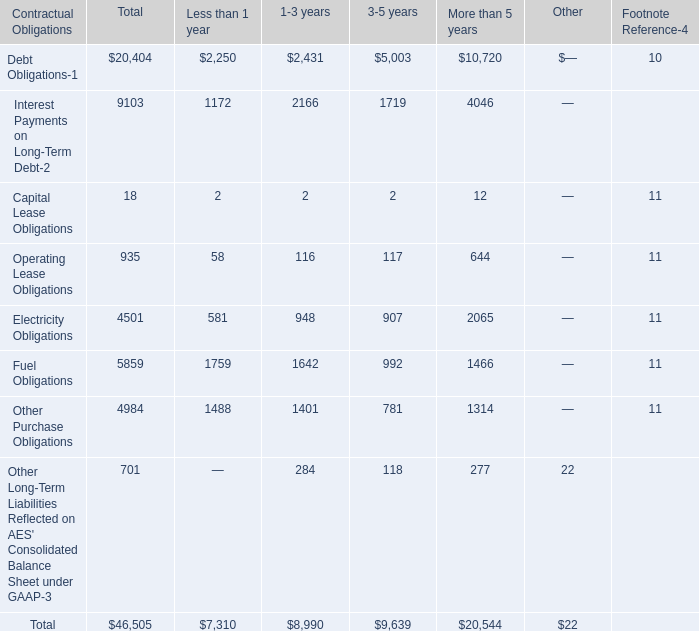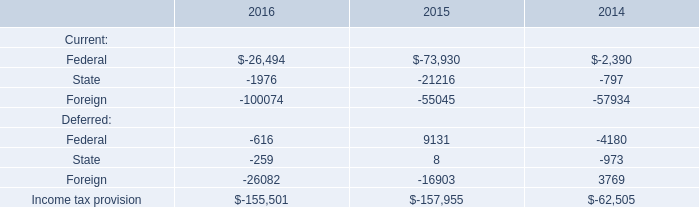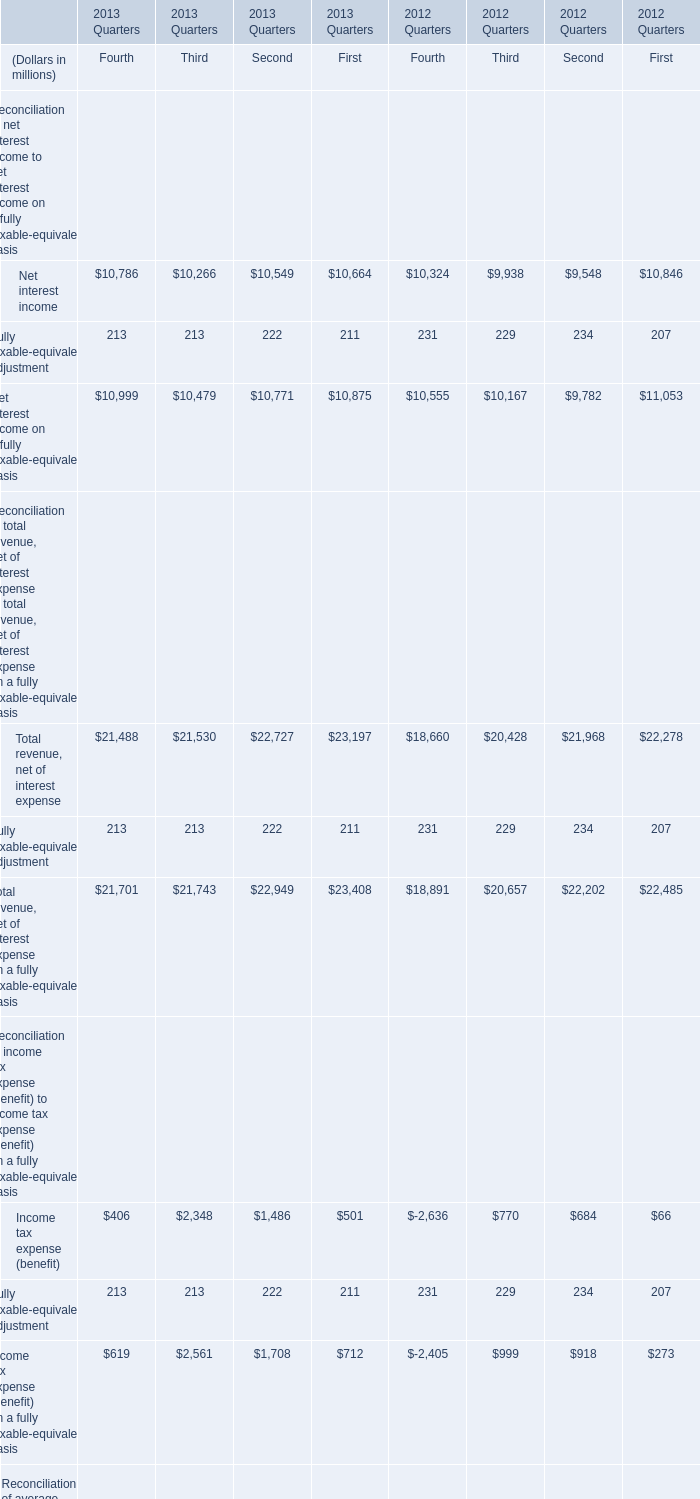what percent of debt obligations are long term? 
Computations: ((20404 - 2250) / 20404)
Answer: 0.88973. 